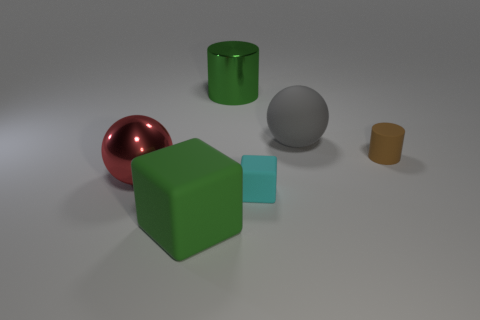Are there any other things of the same color as the matte cylinder?
Your answer should be compact. No. What material is the cyan object that is the same shape as the big green rubber object?
Provide a succinct answer. Rubber. Are there an equal number of spheres that are in front of the small brown object and large spheres on the left side of the big red shiny object?
Your answer should be very brief. No. Are there any small blue blocks that have the same material as the large gray ball?
Your response must be concise. No. Is the big sphere on the left side of the tiny rubber block made of the same material as the big green cylinder?
Offer a terse response. Yes. There is a thing that is behind the red shiny ball and on the left side of the gray sphere; what is its size?
Your answer should be very brief. Large. The metal sphere is what color?
Offer a very short reply. Red. What number of cylinders are there?
Your response must be concise. 2. What number of other cylinders are the same color as the tiny cylinder?
Offer a very short reply. 0. Do the small brown rubber object that is behind the green rubber object and the big green thing that is behind the cyan cube have the same shape?
Your answer should be very brief. Yes. 